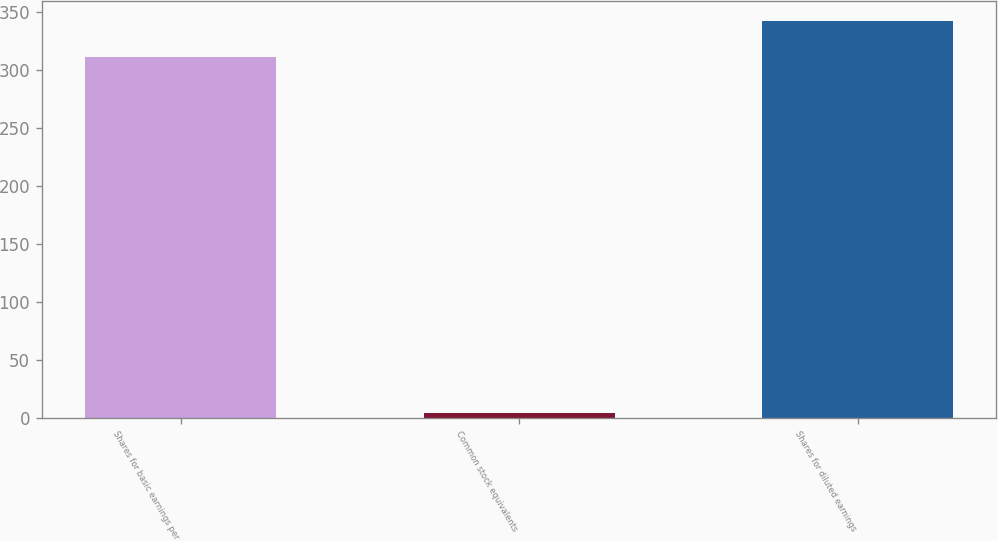Convert chart to OTSL. <chart><loc_0><loc_0><loc_500><loc_500><bar_chart><fcel>Shares for basic earnings per<fcel>Common stock equivalents<fcel>Shares for diluted earnings<nl><fcel>311.4<fcel>4<fcel>342.54<nl></chart> 